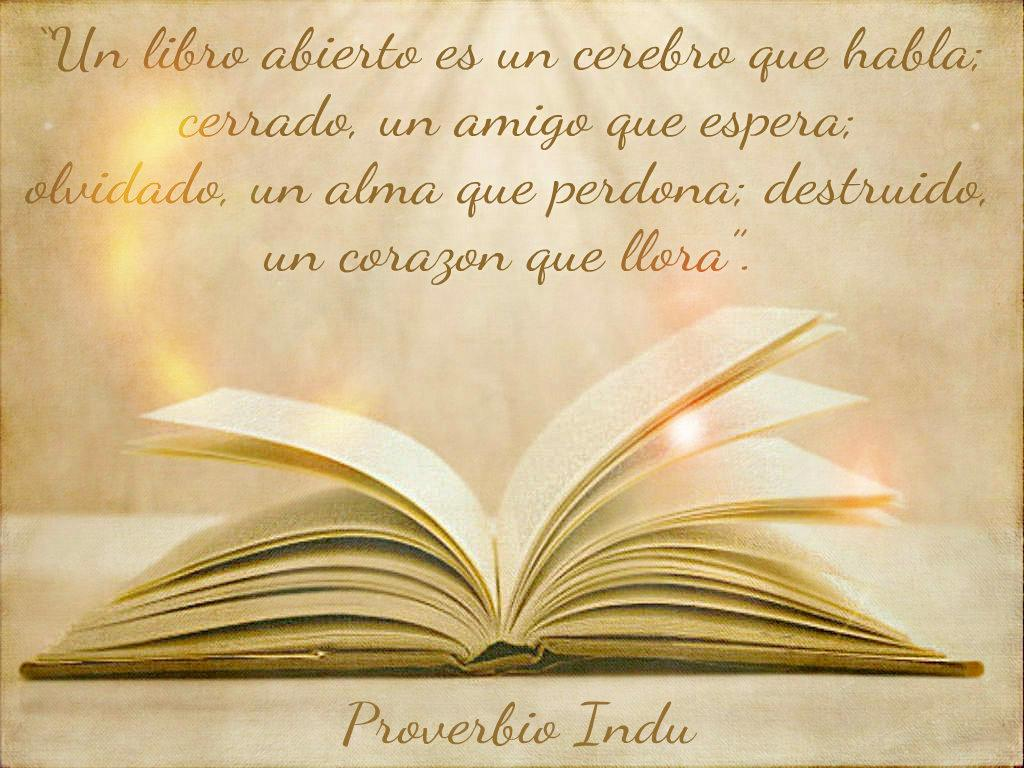<image>
Provide a brief description of the given image. An illustration of an open book with a paragraph in Spanish. 